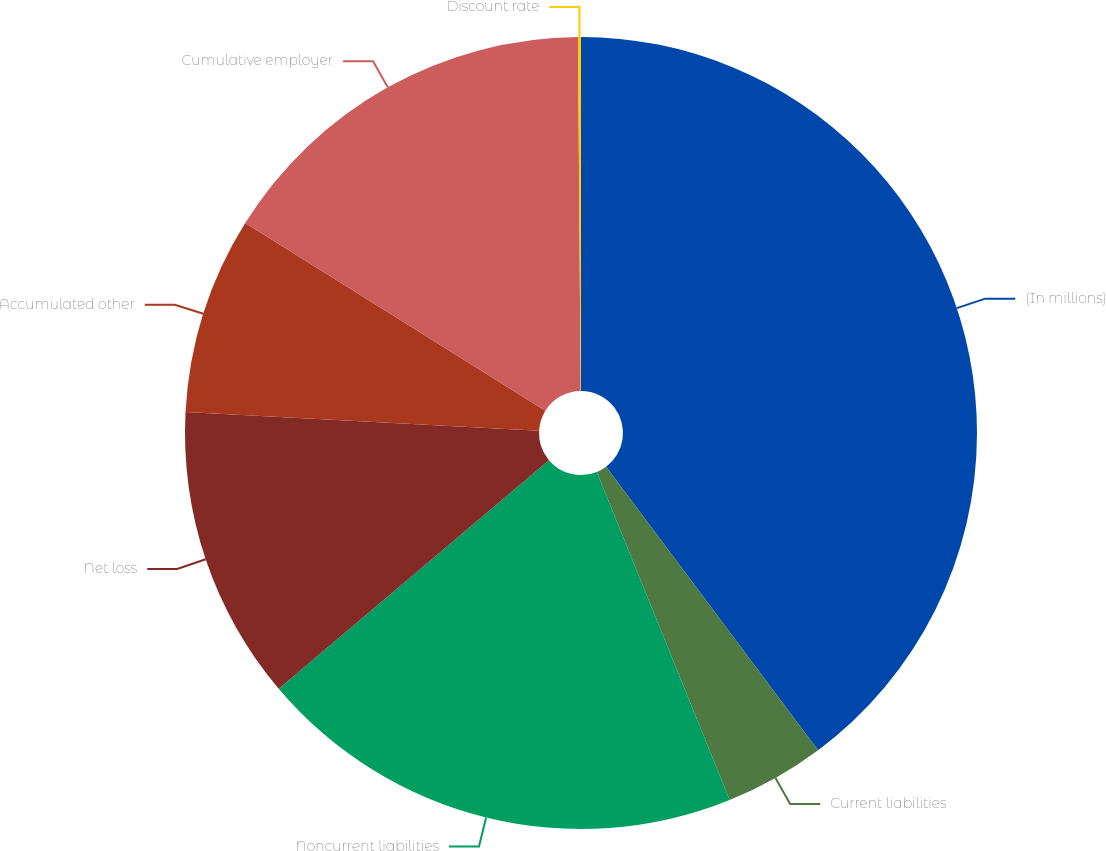<chart> <loc_0><loc_0><loc_500><loc_500><pie_chart><fcel>(In millions)<fcel>Current liabilities<fcel>Noncurrent liabilities<fcel>Net loss<fcel>Accumulated other<fcel>Cumulative employer<fcel>Discount rate<nl><fcel>39.79%<fcel>4.09%<fcel>19.95%<fcel>12.02%<fcel>8.05%<fcel>15.99%<fcel>0.12%<nl></chart> 